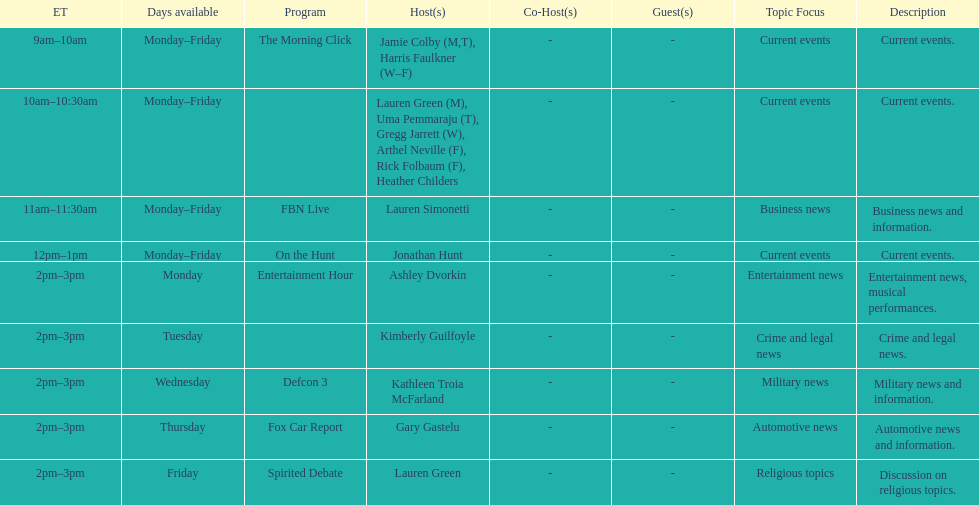How many days is fbn live available each week? 5. 